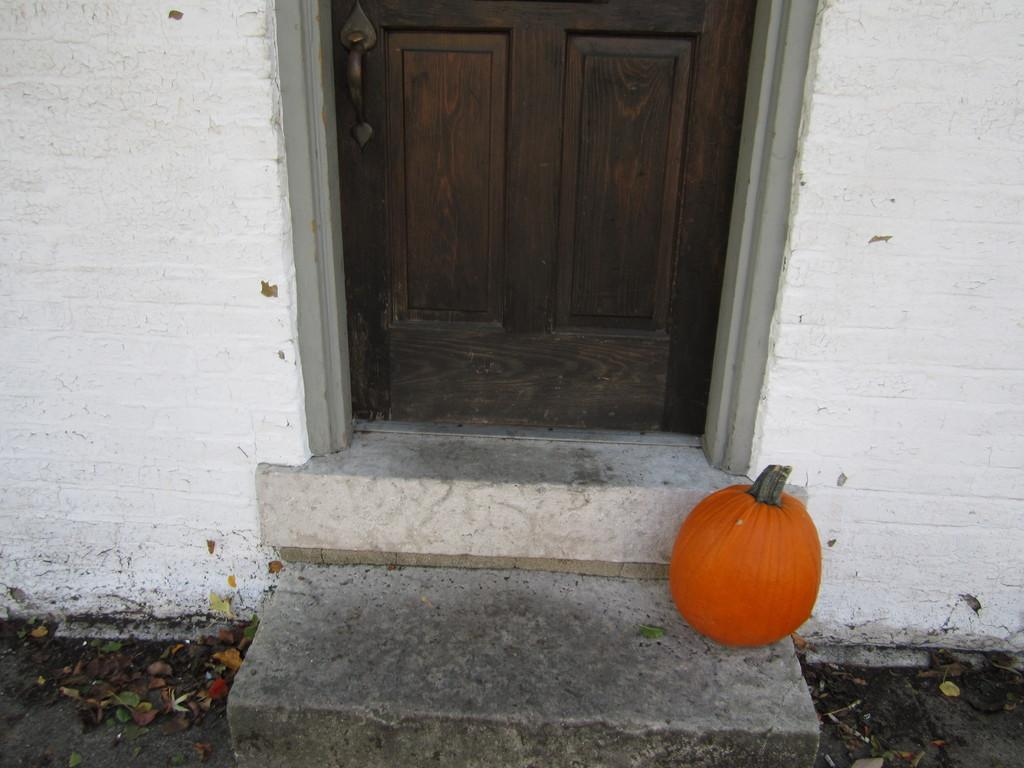What type of door is visible in the image? There is a wooden door in the image. What object is located at the bottom of the image? There is a pumpkin at the bottom of the image. What color is the wall in the image? The wall in the image is white. What type of breakfast is being prepared by the laborer in the image? There is no laborer or breakfast present in the image. What is the temper of the pumpkin in the image? The image does not depict the temper of the pumpkin, as it is an inanimate object and does not have emotions or a temperament. 